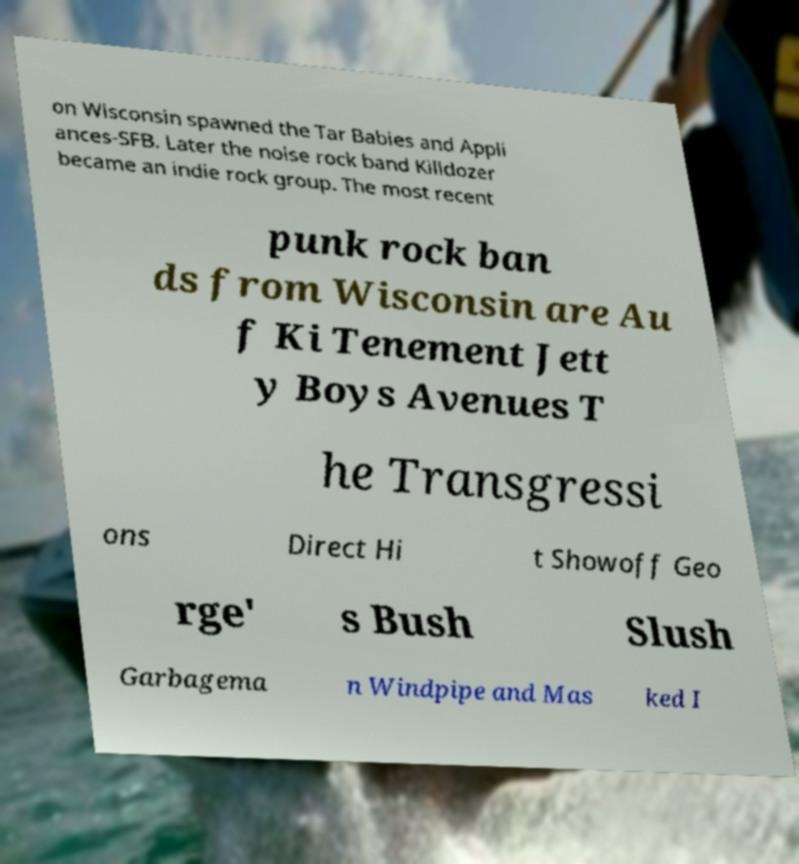Please read and relay the text visible in this image. What does it say? on Wisconsin spawned the Tar Babies and Appli ances-SFB. Later the noise rock band Killdozer became an indie rock group. The most recent punk rock ban ds from Wisconsin are Au f Ki Tenement Jett y Boys Avenues T he Transgressi ons Direct Hi t Showoff Geo rge' s Bush Slush Garbagema n Windpipe and Mas ked I 